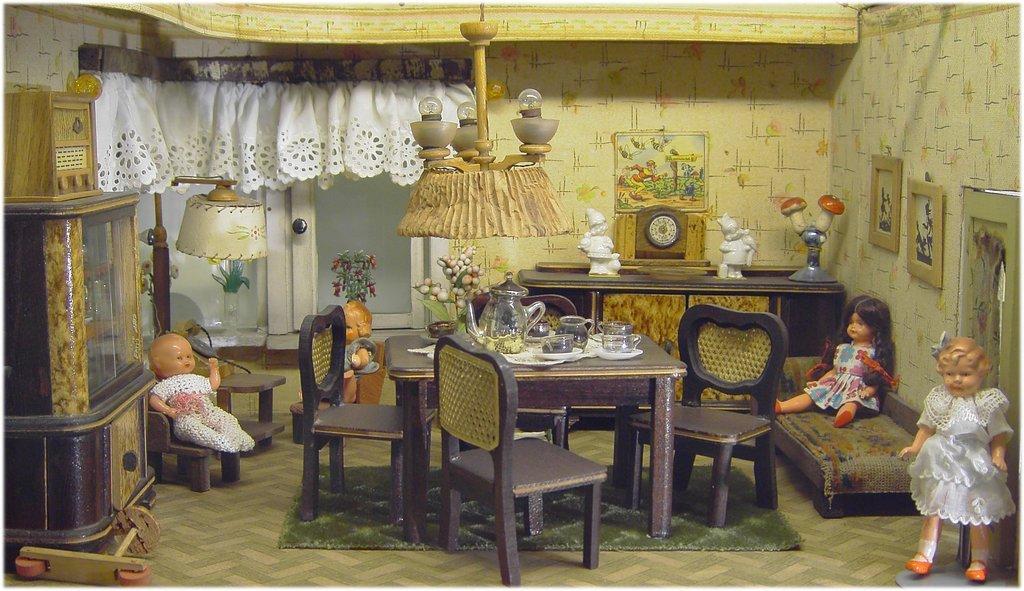Please provide a concise description of this image. In this image there is a dining table with some jars and glasses on it, chandelier on the top, beside that there are some dolls sitting on the couches, and a table with some other things. 